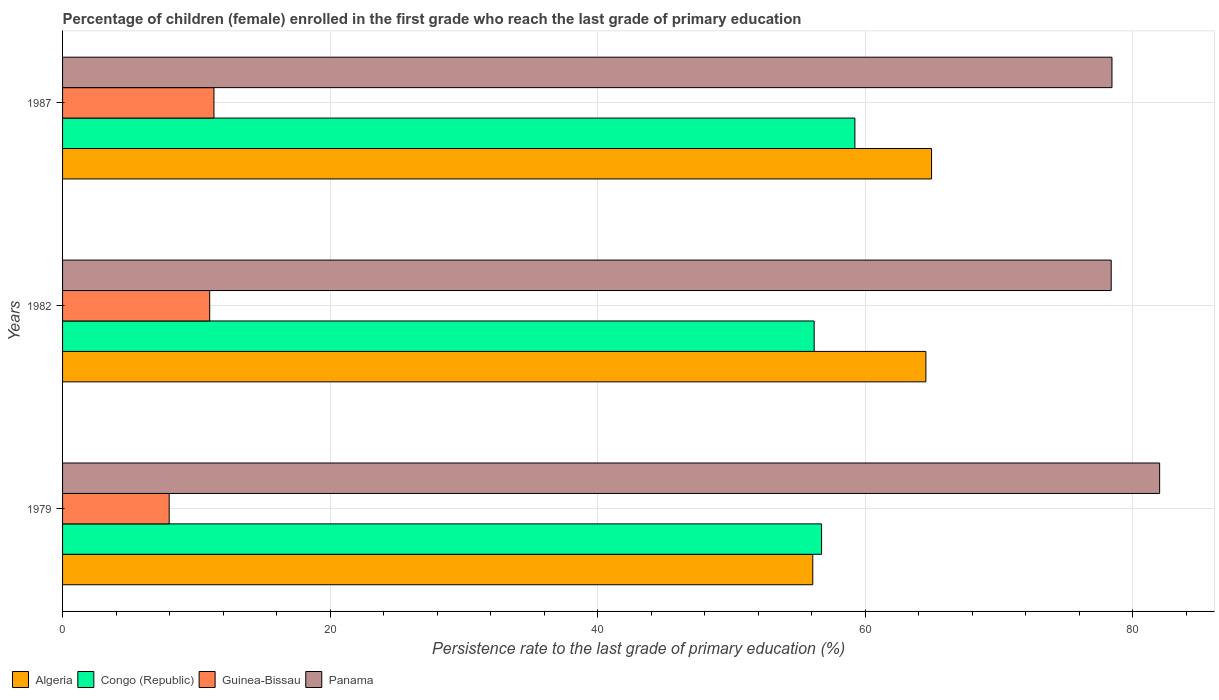How many different coloured bars are there?
Your answer should be very brief. 4. What is the label of the 3rd group of bars from the top?
Provide a succinct answer. 1979. In how many cases, is the number of bars for a given year not equal to the number of legend labels?
Offer a very short reply. 0. What is the persistence rate of children in Algeria in 1982?
Give a very brief answer. 64.54. Across all years, what is the maximum persistence rate of children in Panama?
Offer a very short reply. 82.02. Across all years, what is the minimum persistence rate of children in Guinea-Bissau?
Offer a very short reply. 7.97. In which year was the persistence rate of children in Panama maximum?
Your answer should be compact. 1979. What is the total persistence rate of children in Guinea-Bissau in the graph?
Make the answer very short. 30.29. What is the difference between the persistence rate of children in Guinea-Bissau in 1979 and that in 1982?
Your answer should be very brief. -3.03. What is the difference between the persistence rate of children in Guinea-Bissau in 1979 and the persistence rate of children in Algeria in 1982?
Keep it short and to the point. -56.57. What is the average persistence rate of children in Congo (Republic) per year?
Provide a short and direct response. 57.39. In the year 1982, what is the difference between the persistence rate of children in Algeria and persistence rate of children in Panama?
Your answer should be very brief. -13.85. In how many years, is the persistence rate of children in Algeria greater than 80 %?
Keep it short and to the point. 0. What is the ratio of the persistence rate of children in Panama in 1979 to that in 1982?
Ensure brevity in your answer.  1.05. What is the difference between the highest and the second highest persistence rate of children in Congo (Republic)?
Provide a short and direct response. 2.49. What is the difference between the highest and the lowest persistence rate of children in Congo (Republic)?
Your answer should be compact. 3.05. Is the sum of the persistence rate of children in Congo (Republic) in 1979 and 1987 greater than the maximum persistence rate of children in Guinea-Bissau across all years?
Provide a short and direct response. Yes. Is it the case that in every year, the sum of the persistence rate of children in Guinea-Bissau and persistence rate of children in Congo (Republic) is greater than the sum of persistence rate of children in Panama and persistence rate of children in Algeria?
Ensure brevity in your answer.  No. What does the 3rd bar from the top in 1982 represents?
Provide a short and direct response. Congo (Republic). What does the 4th bar from the bottom in 1987 represents?
Your answer should be compact. Panama. Is it the case that in every year, the sum of the persistence rate of children in Guinea-Bissau and persistence rate of children in Panama is greater than the persistence rate of children in Congo (Republic)?
Your answer should be compact. Yes. Where does the legend appear in the graph?
Offer a terse response. Bottom left. How many legend labels are there?
Your response must be concise. 4. How are the legend labels stacked?
Your answer should be compact. Horizontal. What is the title of the graph?
Your response must be concise. Percentage of children (female) enrolled in the first grade who reach the last grade of primary education. Does "Barbados" appear as one of the legend labels in the graph?
Ensure brevity in your answer.  No. What is the label or title of the X-axis?
Give a very brief answer. Persistence rate to the last grade of primary education (%). What is the Persistence rate to the last grade of primary education (%) in Algeria in 1979?
Make the answer very short. 56.09. What is the Persistence rate to the last grade of primary education (%) of Congo (Republic) in 1979?
Provide a short and direct response. 56.74. What is the Persistence rate to the last grade of primary education (%) in Guinea-Bissau in 1979?
Keep it short and to the point. 7.97. What is the Persistence rate to the last grade of primary education (%) of Panama in 1979?
Ensure brevity in your answer.  82.02. What is the Persistence rate to the last grade of primary education (%) in Algeria in 1982?
Provide a short and direct response. 64.54. What is the Persistence rate to the last grade of primary education (%) of Congo (Republic) in 1982?
Make the answer very short. 56.19. What is the Persistence rate to the last grade of primary education (%) in Guinea-Bissau in 1982?
Your response must be concise. 11. What is the Persistence rate to the last grade of primary education (%) of Panama in 1982?
Your answer should be very brief. 78.4. What is the Persistence rate to the last grade of primary education (%) of Algeria in 1987?
Provide a succinct answer. 64.97. What is the Persistence rate to the last grade of primary education (%) in Congo (Republic) in 1987?
Give a very brief answer. 59.24. What is the Persistence rate to the last grade of primary education (%) of Guinea-Bissau in 1987?
Offer a very short reply. 11.32. What is the Persistence rate to the last grade of primary education (%) of Panama in 1987?
Give a very brief answer. 78.46. Across all years, what is the maximum Persistence rate to the last grade of primary education (%) of Algeria?
Ensure brevity in your answer.  64.97. Across all years, what is the maximum Persistence rate to the last grade of primary education (%) of Congo (Republic)?
Your answer should be compact. 59.24. Across all years, what is the maximum Persistence rate to the last grade of primary education (%) of Guinea-Bissau?
Keep it short and to the point. 11.32. Across all years, what is the maximum Persistence rate to the last grade of primary education (%) of Panama?
Provide a succinct answer. 82.02. Across all years, what is the minimum Persistence rate to the last grade of primary education (%) of Algeria?
Your answer should be very brief. 56.09. Across all years, what is the minimum Persistence rate to the last grade of primary education (%) of Congo (Republic)?
Provide a succinct answer. 56.19. Across all years, what is the minimum Persistence rate to the last grade of primary education (%) of Guinea-Bissau?
Give a very brief answer. 7.97. Across all years, what is the minimum Persistence rate to the last grade of primary education (%) in Panama?
Provide a succinct answer. 78.4. What is the total Persistence rate to the last grade of primary education (%) in Algeria in the graph?
Your response must be concise. 185.6. What is the total Persistence rate to the last grade of primary education (%) of Congo (Republic) in the graph?
Your answer should be compact. 172.17. What is the total Persistence rate to the last grade of primary education (%) of Guinea-Bissau in the graph?
Make the answer very short. 30.29. What is the total Persistence rate to the last grade of primary education (%) in Panama in the graph?
Your answer should be very brief. 238.87. What is the difference between the Persistence rate to the last grade of primary education (%) of Algeria in 1979 and that in 1982?
Keep it short and to the point. -8.46. What is the difference between the Persistence rate to the last grade of primary education (%) in Congo (Republic) in 1979 and that in 1982?
Provide a short and direct response. 0.56. What is the difference between the Persistence rate to the last grade of primary education (%) in Guinea-Bissau in 1979 and that in 1982?
Offer a very short reply. -3.03. What is the difference between the Persistence rate to the last grade of primary education (%) in Panama in 1979 and that in 1982?
Keep it short and to the point. 3.62. What is the difference between the Persistence rate to the last grade of primary education (%) in Algeria in 1979 and that in 1987?
Your response must be concise. -8.88. What is the difference between the Persistence rate to the last grade of primary education (%) in Congo (Republic) in 1979 and that in 1987?
Your answer should be compact. -2.49. What is the difference between the Persistence rate to the last grade of primary education (%) of Guinea-Bissau in 1979 and that in 1987?
Ensure brevity in your answer.  -3.35. What is the difference between the Persistence rate to the last grade of primary education (%) in Panama in 1979 and that in 1987?
Offer a terse response. 3.56. What is the difference between the Persistence rate to the last grade of primary education (%) in Algeria in 1982 and that in 1987?
Provide a short and direct response. -0.42. What is the difference between the Persistence rate to the last grade of primary education (%) of Congo (Republic) in 1982 and that in 1987?
Ensure brevity in your answer.  -3.05. What is the difference between the Persistence rate to the last grade of primary education (%) of Guinea-Bissau in 1982 and that in 1987?
Your answer should be very brief. -0.32. What is the difference between the Persistence rate to the last grade of primary education (%) of Panama in 1982 and that in 1987?
Give a very brief answer. -0.06. What is the difference between the Persistence rate to the last grade of primary education (%) in Algeria in 1979 and the Persistence rate to the last grade of primary education (%) in Congo (Republic) in 1982?
Keep it short and to the point. -0.1. What is the difference between the Persistence rate to the last grade of primary education (%) of Algeria in 1979 and the Persistence rate to the last grade of primary education (%) of Guinea-Bissau in 1982?
Provide a short and direct response. 45.09. What is the difference between the Persistence rate to the last grade of primary education (%) in Algeria in 1979 and the Persistence rate to the last grade of primary education (%) in Panama in 1982?
Your response must be concise. -22.31. What is the difference between the Persistence rate to the last grade of primary education (%) of Congo (Republic) in 1979 and the Persistence rate to the last grade of primary education (%) of Guinea-Bissau in 1982?
Make the answer very short. 45.74. What is the difference between the Persistence rate to the last grade of primary education (%) of Congo (Republic) in 1979 and the Persistence rate to the last grade of primary education (%) of Panama in 1982?
Your answer should be compact. -21.65. What is the difference between the Persistence rate to the last grade of primary education (%) of Guinea-Bissau in 1979 and the Persistence rate to the last grade of primary education (%) of Panama in 1982?
Provide a succinct answer. -70.43. What is the difference between the Persistence rate to the last grade of primary education (%) in Algeria in 1979 and the Persistence rate to the last grade of primary education (%) in Congo (Republic) in 1987?
Provide a short and direct response. -3.15. What is the difference between the Persistence rate to the last grade of primary education (%) of Algeria in 1979 and the Persistence rate to the last grade of primary education (%) of Guinea-Bissau in 1987?
Ensure brevity in your answer.  44.77. What is the difference between the Persistence rate to the last grade of primary education (%) of Algeria in 1979 and the Persistence rate to the last grade of primary education (%) of Panama in 1987?
Your answer should be compact. -22.37. What is the difference between the Persistence rate to the last grade of primary education (%) of Congo (Republic) in 1979 and the Persistence rate to the last grade of primary education (%) of Guinea-Bissau in 1987?
Make the answer very short. 45.43. What is the difference between the Persistence rate to the last grade of primary education (%) of Congo (Republic) in 1979 and the Persistence rate to the last grade of primary education (%) of Panama in 1987?
Your answer should be compact. -21.71. What is the difference between the Persistence rate to the last grade of primary education (%) of Guinea-Bissau in 1979 and the Persistence rate to the last grade of primary education (%) of Panama in 1987?
Ensure brevity in your answer.  -70.48. What is the difference between the Persistence rate to the last grade of primary education (%) in Algeria in 1982 and the Persistence rate to the last grade of primary education (%) in Congo (Republic) in 1987?
Provide a succinct answer. 5.31. What is the difference between the Persistence rate to the last grade of primary education (%) in Algeria in 1982 and the Persistence rate to the last grade of primary education (%) in Guinea-Bissau in 1987?
Ensure brevity in your answer.  53.23. What is the difference between the Persistence rate to the last grade of primary education (%) in Algeria in 1982 and the Persistence rate to the last grade of primary education (%) in Panama in 1987?
Your answer should be compact. -13.91. What is the difference between the Persistence rate to the last grade of primary education (%) in Congo (Republic) in 1982 and the Persistence rate to the last grade of primary education (%) in Guinea-Bissau in 1987?
Make the answer very short. 44.87. What is the difference between the Persistence rate to the last grade of primary education (%) in Congo (Republic) in 1982 and the Persistence rate to the last grade of primary education (%) in Panama in 1987?
Keep it short and to the point. -22.27. What is the difference between the Persistence rate to the last grade of primary education (%) of Guinea-Bissau in 1982 and the Persistence rate to the last grade of primary education (%) of Panama in 1987?
Your response must be concise. -67.45. What is the average Persistence rate to the last grade of primary education (%) of Algeria per year?
Give a very brief answer. 61.87. What is the average Persistence rate to the last grade of primary education (%) of Congo (Republic) per year?
Make the answer very short. 57.39. What is the average Persistence rate to the last grade of primary education (%) in Guinea-Bissau per year?
Your response must be concise. 10.1. What is the average Persistence rate to the last grade of primary education (%) of Panama per year?
Keep it short and to the point. 79.62. In the year 1979, what is the difference between the Persistence rate to the last grade of primary education (%) in Algeria and Persistence rate to the last grade of primary education (%) in Congo (Republic)?
Provide a short and direct response. -0.66. In the year 1979, what is the difference between the Persistence rate to the last grade of primary education (%) of Algeria and Persistence rate to the last grade of primary education (%) of Guinea-Bissau?
Provide a succinct answer. 48.12. In the year 1979, what is the difference between the Persistence rate to the last grade of primary education (%) in Algeria and Persistence rate to the last grade of primary education (%) in Panama?
Keep it short and to the point. -25.93. In the year 1979, what is the difference between the Persistence rate to the last grade of primary education (%) in Congo (Republic) and Persistence rate to the last grade of primary education (%) in Guinea-Bissau?
Keep it short and to the point. 48.77. In the year 1979, what is the difference between the Persistence rate to the last grade of primary education (%) in Congo (Republic) and Persistence rate to the last grade of primary education (%) in Panama?
Your response must be concise. -25.27. In the year 1979, what is the difference between the Persistence rate to the last grade of primary education (%) in Guinea-Bissau and Persistence rate to the last grade of primary education (%) in Panama?
Give a very brief answer. -74.05. In the year 1982, what is the difference between the Persistence rate to the last grade of primary education (%) of Algeria and Persistence rate to the last grade of primary education (%) of Congo (Republic)?
Make the answer very short. 8.35. In the year 1982, what is the difference between the Persistence rate to the last grade of primary education (%) of Algeria and Persistence rate to the last grade of primary education (%) of Guinea-Bissau?
Offer a terse response. 53.54. In the year 1982, what is the difference between the Persistence rate to the last grade of primary education (%) of Algeria and Persistence rate to the last grade of primary education (%) of Panama?
Give a very brief answer. -13.85. In the year 1982, what is the difference between the Persistence rate to the last grade of primary education (%) of Congo (Republic) and Persistence rate to the last grade of primary education (%) of Guinea-Bissau?
Make the answer very short. 45.19. In the year 1982, what is the difference between the Persistence rate to the last grade of primary education (%) in Congo (Republic) and Persistence rate to the last grade of primary education (%) in Panama?
Ensure brevity in your answer.  -22.21. In the year 1982, what is the difference between the Persistence rate to the last grade of primary education (%) of Guinea-Bissau and Persistence rate to the last grade of primary education (%) of Panama?
Your answer should be compact. -67.4. In the year 1987, what is the difference between the Persistence rate to the last grade of primary education (%) of Algeria and Persistence rate to the last grade of primary education (%) of Congo (Republic)?
Keep it short and to the point. 5.73. In the year 1987, what is the difference between the Persistence rate to the last grade of primary education (%) of Algeria and Persistence rate to the last grade of primary education (%) of Guinea-Bissau?
Make the answer very short. 53.65. In the year 1987, what is the difference between the Persistence rate to the last grade of primary education (%) of Algeria and Persistence rate to the last grade of primary education (%) of Panama?
Provide a short and direct response. -13.49. In the year 1987, what is the difference between the Persistence rate to the last grade of primary education (%) in Congo (Republic) and Persistence rate to the last grade of primary education (%) in Guinea-Bissau?
Offer a very short reply. 47.92. In the year 1987, what is the difference between the Persistence rate to the last grade of primary education (%) in Congo (Republic) and Persistence rate to the last grade of primary education (%) in Panama?
Provide a succinct answer. -19.22. In the year 1987, what is the difference between the Persistence rate to the last grade of primary education (%) in Guinea-Bissau and Persistence rate to the last grade of primary education (%) in Panama?
Offer a very short reply. -67.14. What is the ratio of the Persistence rate to the last grade of primary education (%) in Algeria in 1979 to that in 1982?
Offer a very short reply. 0.87. What is the ratio of the Persistence rate to the last grade of primary education (%) in Congo (Republic) in 1979 to that in 1982?
Provide a succinct answer. 1.01. What is the ratio of the Persistence rate to the last grade of primary education (%) in Guinea-Bissau in 1979 to that in 1982?
Your response must be concise. 0.72. What is the ratio of the Persistence rate to the last grade of primary education (%) in Panama in 1979 to that in 1982?
Give a very brief answer. 1.05. What is the ratio of the Persistence rate to the last grade of primary education (%) of Algeria in 1979 to that in 1987?
Provide a short and direct response. 0.86. What is the ratio of the Persistence rate to the last grade of primary education (%) of Congo (Republic) in 1979 to that in 1987?
Ensure brevity in your answer.  0.96. What is the ratio of the Persistence rate to the last grade of primary education (%) of Guinea-Bissau in 1979 to that in 1987?
Your answer should be very brief. 0.7. What is the ratio of the Persistence rate to the last grade of primary education (%) in Panama in 1979 to that in 1987?
Provide a succinct answer. 1.05. What is the ratio of the Persistence rate to the last grade of primary education (%) of Congo (Republic) in 1982 to that in 1987?
Your answer should be very brief. 0.95. What is the ratio of the Persistence rate to the last grade of primary education (%) in Guinea-Bissau in 1982 to that in 1987?
Provide a short and direct response. 0.97. What is the ratio of the Persistence rate to the last grade of primary education (%) in Panama in 1982 to that in 1987?
Provide a succinct answer. 1. What is the difference between the highest and the second highest Persistence rate to the last grade of primary education (%) in Algeria?
Offer a very short reply. 0.42. What is the difference between the highest and the second highest Persistence rate to the last grade of primary education (%) in Congo (Republic)?
Offer a terse response. 2.49. What is the difference between the highest and the second highest Persistence rate to the last grade of primary education (%) of Guinea-Bissau?
Your answer should be compact. 0.32. What is the difference between the highest and the second highest Persistence rate to the last grade of primary education (%) in Panama?
Make the answer very short. 3.56. What is the difference between the highest and the lowest Persistence rate to the last grade of primary education (%) in Algeria?
Make the answer very short. 8.88. What is the difference between the highest and the lowest Persistence rate to the last grade of primary education (%) of Congo (Republic)?
Keep it short and to the point. 3.05. What is the difference between the highest and the lowest Persistence rate to the last grade of primary education (%) of Guinea-Bissau?
Offer a very short reply. 3.35. What is the difference between the highest and the lowest Persistence rate to the last grade of primary education (%) of Panama?
Offer a terse response. 3.62. 